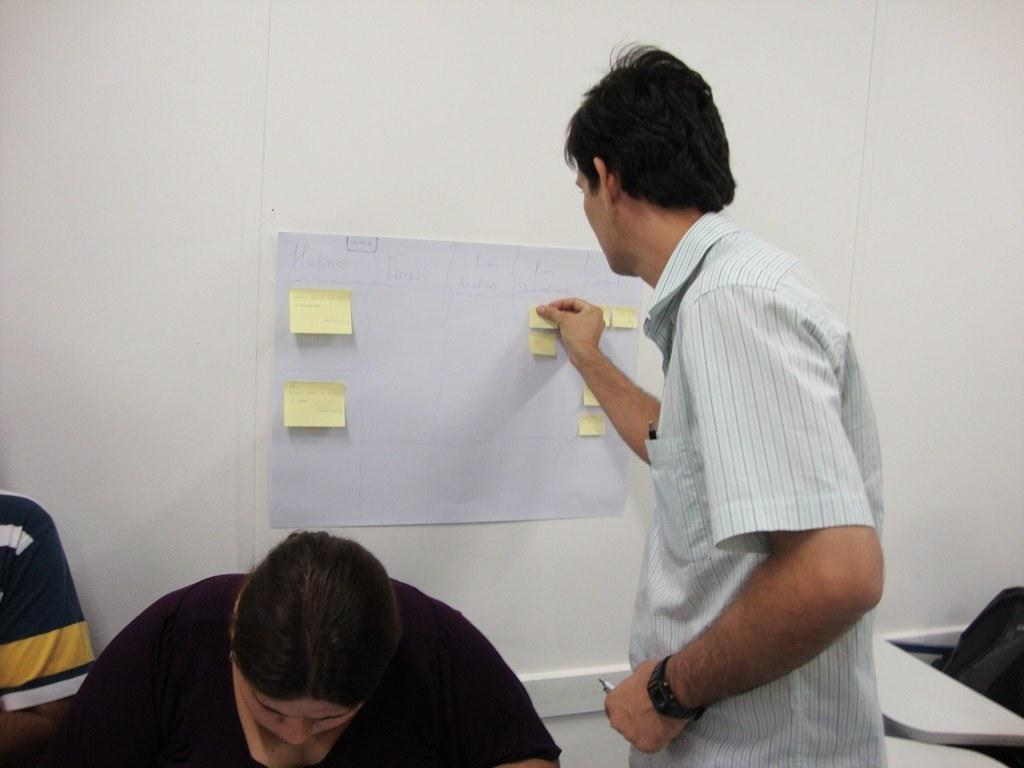How many people are present in the image? There are two persons sitting in the image. What is the man in the image doing? The man is standing and sticking a paper on another paper on the wall. Can you describe the objects in the image? There are some objects in the image, but their specific details are not mentioned in the provided facts. What type of brass instrument is the man playing in the image? There is no brass instrument present in the image; the man is sticking a paper on another paper on the wall. What kind of bag is the person sitting on the left side of the image holding? There is no bag mentioned or visible in the image. 